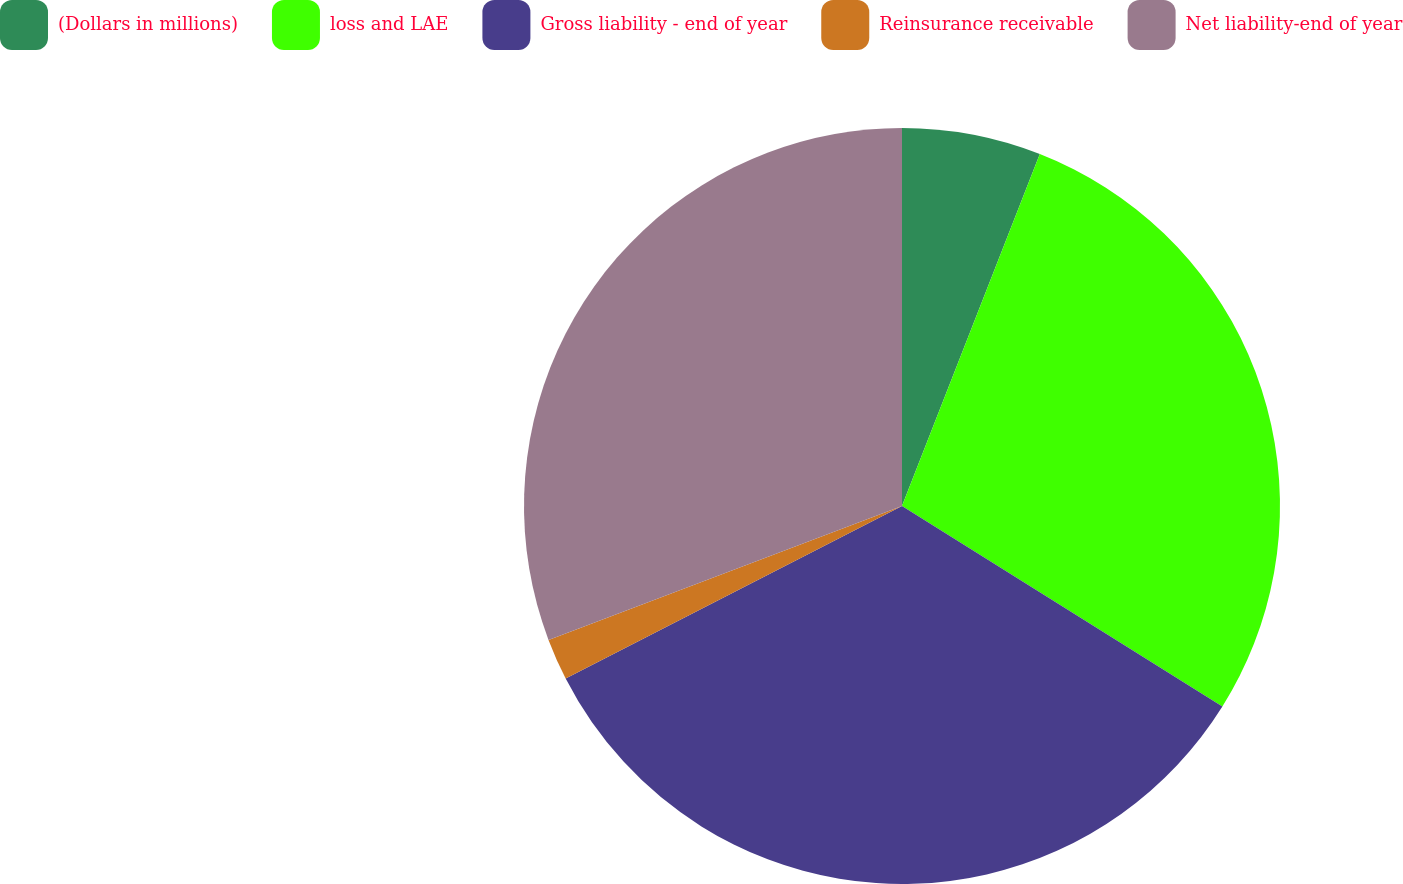<chart> <loc_0><loc_0><loc_500><loc_500><pie_chart><fcel>(Dollars in millions)<fcel>loss and LAE<fcel>Gross liability - end of year<fcel>Reinsurance receivable<fcel>Net liability-end of year<nl><fcel>5.94%<fcel>27.96%<fcel>33.55%<fcel>1.78%<fcel>30.76%<nl></chart> 